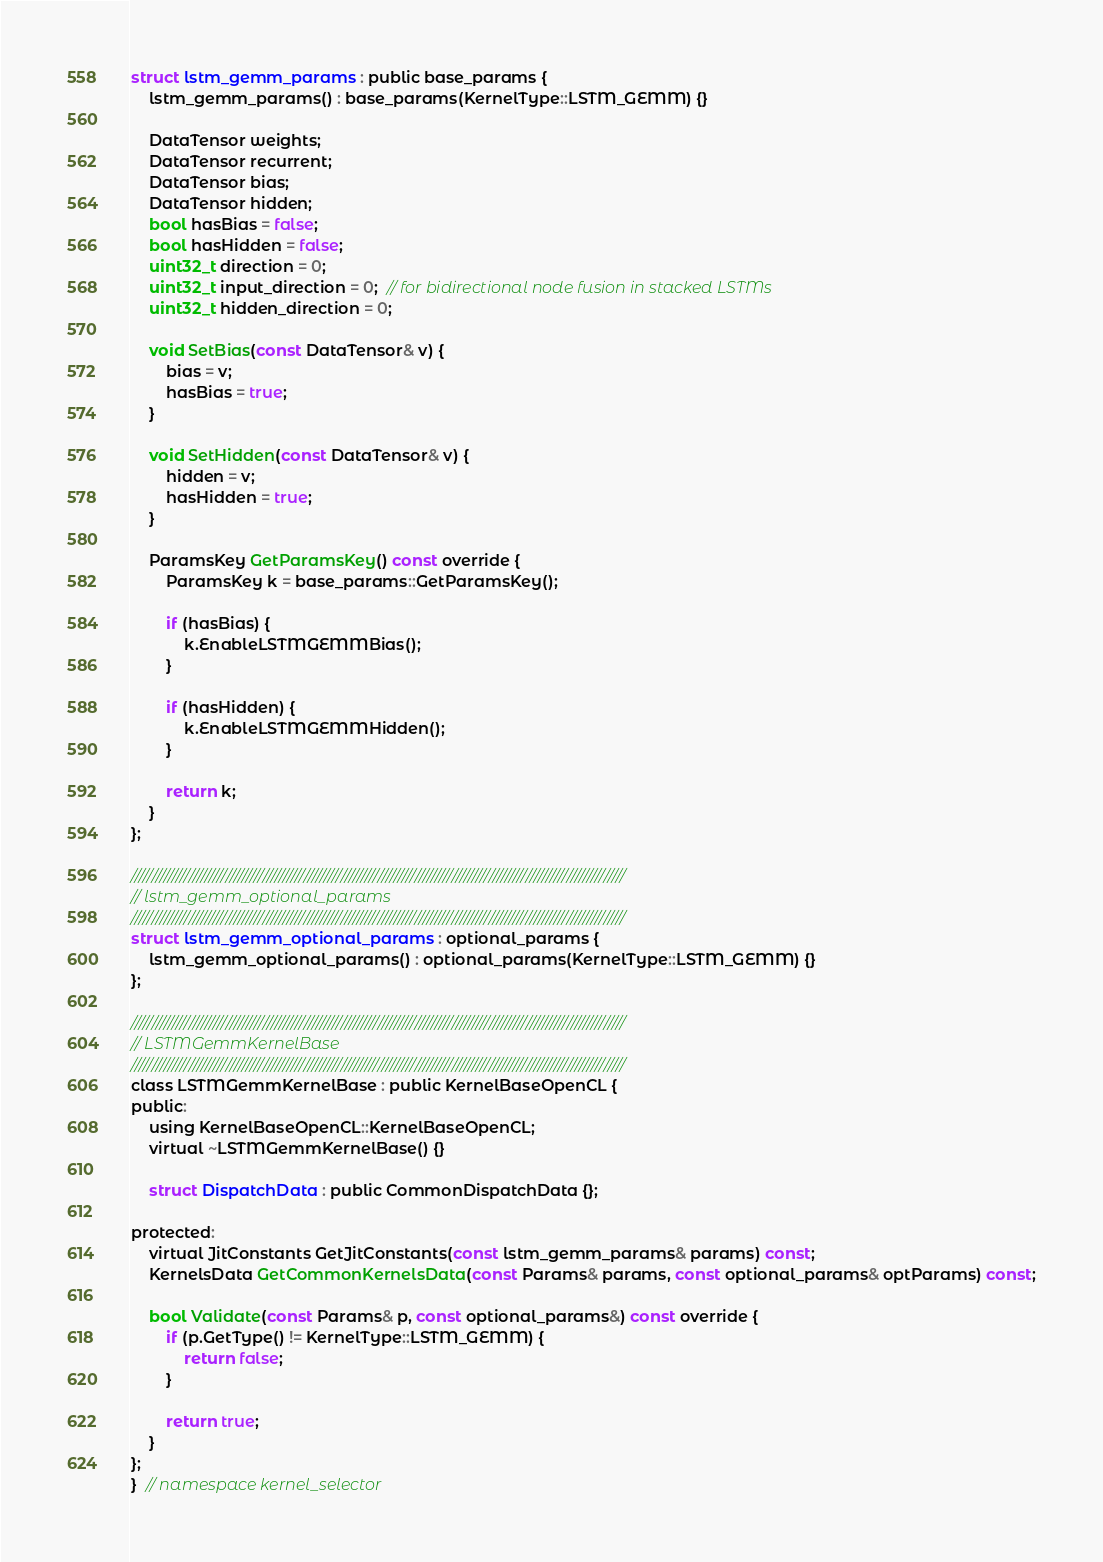Convert code to text. <code><loc_0><loc_0><loc_500><loc_500><_C_>struct lstm_gemm_params : public base_params {
    lstm_gemm_params() : base_params(KernelType::LSTM_GEMM) {}

    DataTensor weights;
    DataTensor recurrent;
    DataTensor bias;
    DataTensor hidden;
    bool hasBias = false;
    bool hasHidden = false;
    uint32_t direction = 0;
    uint32_t input_direction = 0;  // for bidirectional node fusion in stacked LSTMs
    uint32_t hidden_direction = 0;

    void SetBias(const DataTensor& v) {
        bias = v;
        hasBias = true;
    }

    void SetHidden(const DataTensor& v) {
        hidden = v;
        hasHidden = true;
    }

    ParamsKey GetParamsKey() const override {
        ParamsKey k = base_params::GetParamsKey();

        if (hasBias) {
            k.EnableLSTMGEMMBias();
        }

        if (hasHidden) {
            k.EnableLSTMGEMMHidden();
        }

        return k;
    }
};

////////////////////////////////////////////////////////////////////////////////////////////////////////////////////////
// lstm_gemm_optional_params
////////////////////////////////////////////////////////////////////////////////////////////////////////////////////////
struct lstm_gemm_optional_params : optional_params {
    lstm_gemm_optional_params() : optional_params(KernelType::LSTM_GEMM) {}
};

////////////////////////////////////////////////////////////////////////////////////////////////////////////////////////
// LSTMGemmKernelBase
////////////////////////////////////////////////////////////////////////////////////////////////////////////////////////
class LSTMGemmKernelBase : public KernelBaseOpenCL {
public:
    using KernelBaseOpenCL::KernelBaseOpenCL;
    virtual ~LSTMGemmKernelBase() {}

    struct DispatchData : public CommonDispatchData {};

protected:
    virtual JitConstants GetJitConstants(const lstm_gemm_params& params) const;
    KernelsData GetCommonKernelsData(const Params& params, const optional_params& optParams) const;

    bool Validate(const Params& p, const optional_params&) const override {
        if (p.GetType() != KernelType::LSTM_GEMM) {
            return false;
        }

        return true;
    }
};
}  // namespace kernel_selector
</code> 